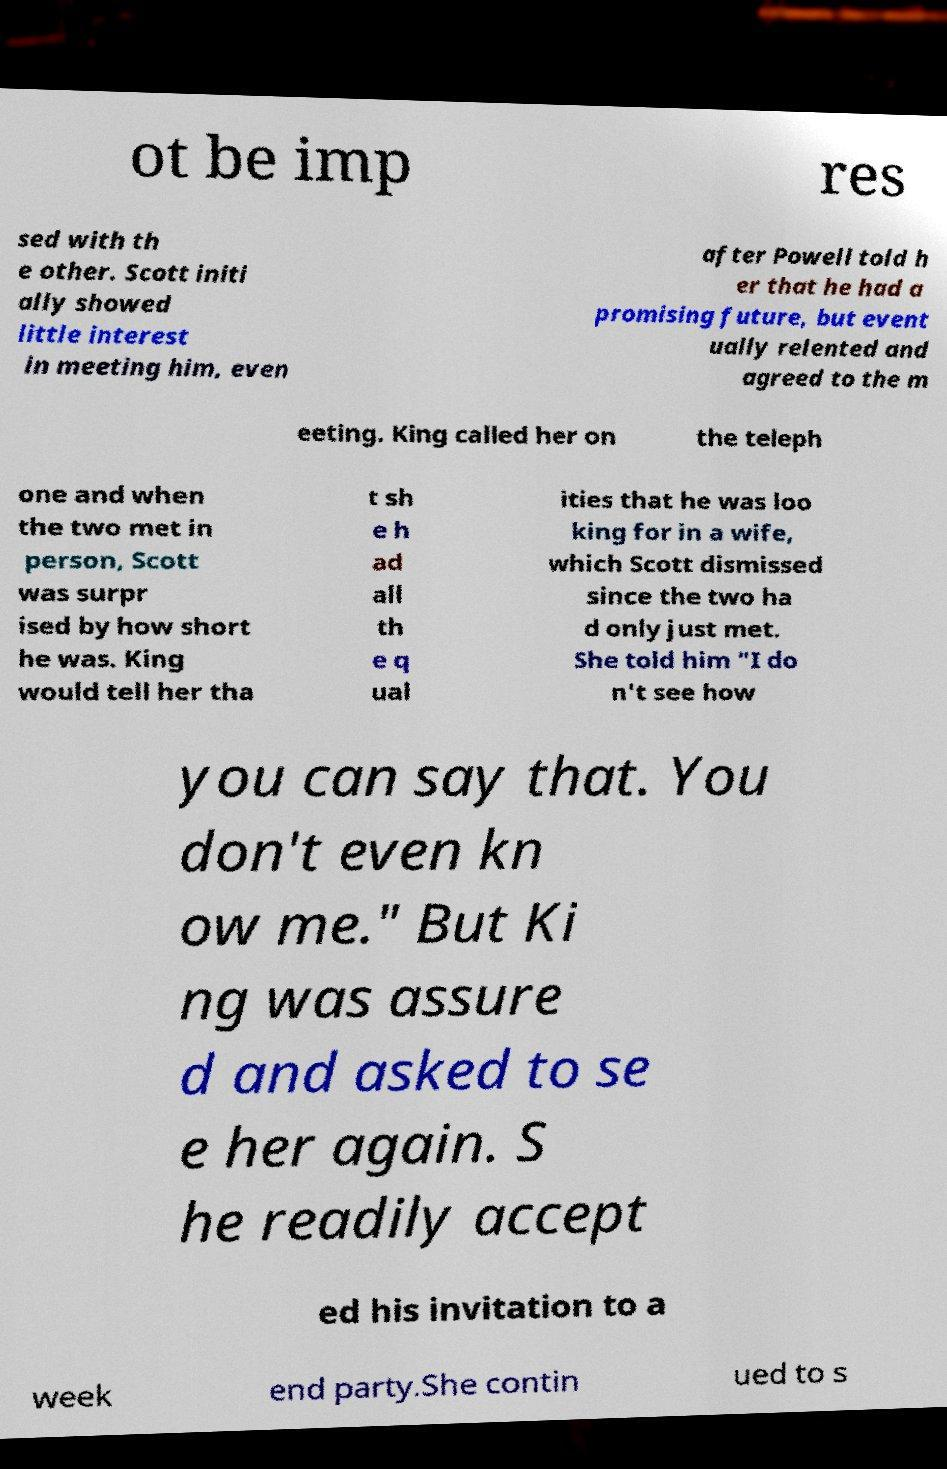I need the written content from this picture converted into text. Can you do that? ot be imp res sed with th e other. Scott initi ally showed little interest in meeting him, even after Powell told h er that he had a promising future, but event ually relented and agreed to the m eeting. King called her on the teleph one and when the two met in person, Scott was surpr ised by how short he was. King would tell her tha t sh e h ad all th e q ual ities that he was loo king for in a wife, which Scott dismissed since the two ha d only just met. She told him "I do n't see how you can say that. You don't even kn ow me." But Ki ng was assure d and asked to se e her again. S he readily accept ed his invitation to a week end party.She contin ued to s 